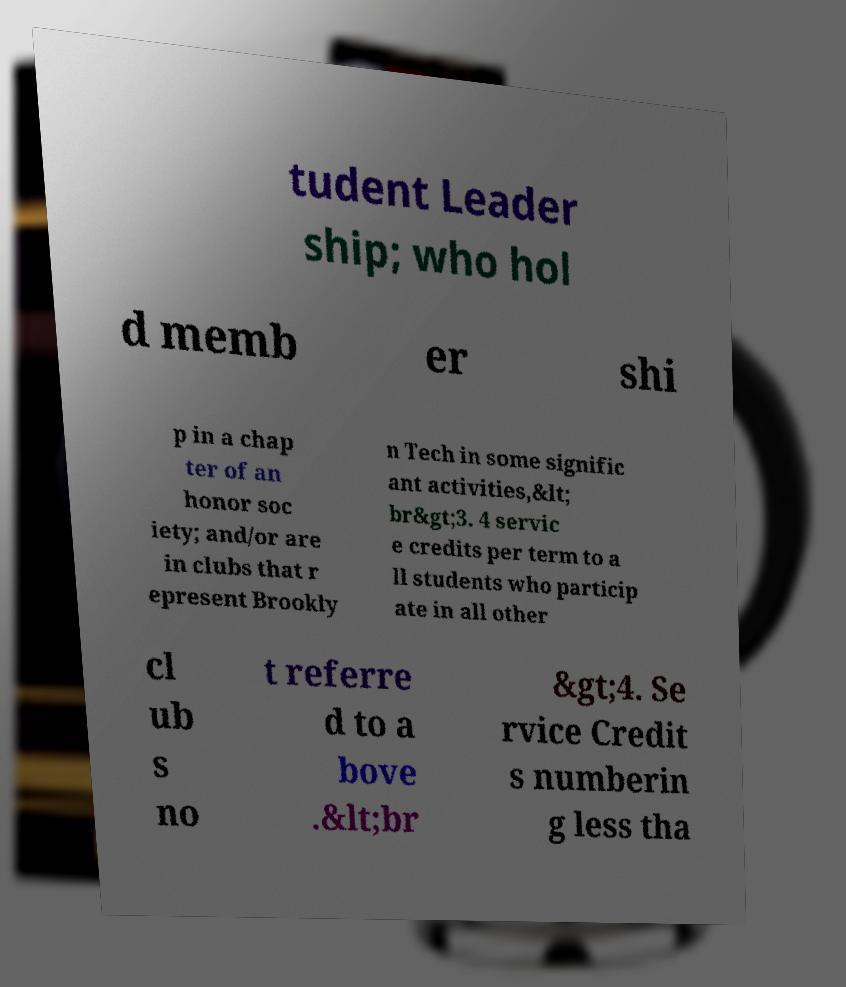Could you assist in decoding the text presented in this image and type it out clearly? tudent Leader ship; who hol d memb er shi p in a chap ter of an honor soc iety; and/or are in clubs that r epresent Brookly n Tech in some signific ant activities,&lt; br&gt;3. 4 servic e credits per term to a ll students who particip ate in all other cl ub s no t referre d to a bove .&lt;br &gt;4. Se rvice Credit s numberin g less tha 